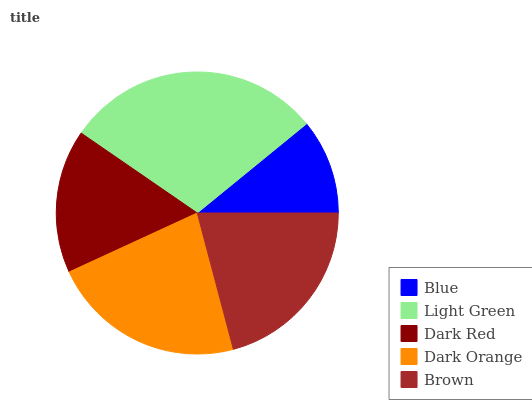Is Blue the minimum?
Answer yes or no. Yes. Is Light Green the maximum?
Answer yes or no. Yes. Is Dark Red the minimum?
Answer yes or no. No. Is Dark Red the maximum?
Answer yes or no. No. Is Light Green greater than Dark Red?
Answer yes or no. Yes. Is Dark Red less than Light Green?
Answer yes or no. Yes. Is Dark Red greater than Light Green?
Answer yes or no. No. Is Light Green less than Dark Red?
Answer yes or no. No. Is Brown the high median?
Answer yes or no. Yes. Is Brown the low median?
Answer yes or no. Yes. Is Dark Red the high median?
Answer yes or no. No. Is Dark Red the low median?
Answer yes or no. No. 